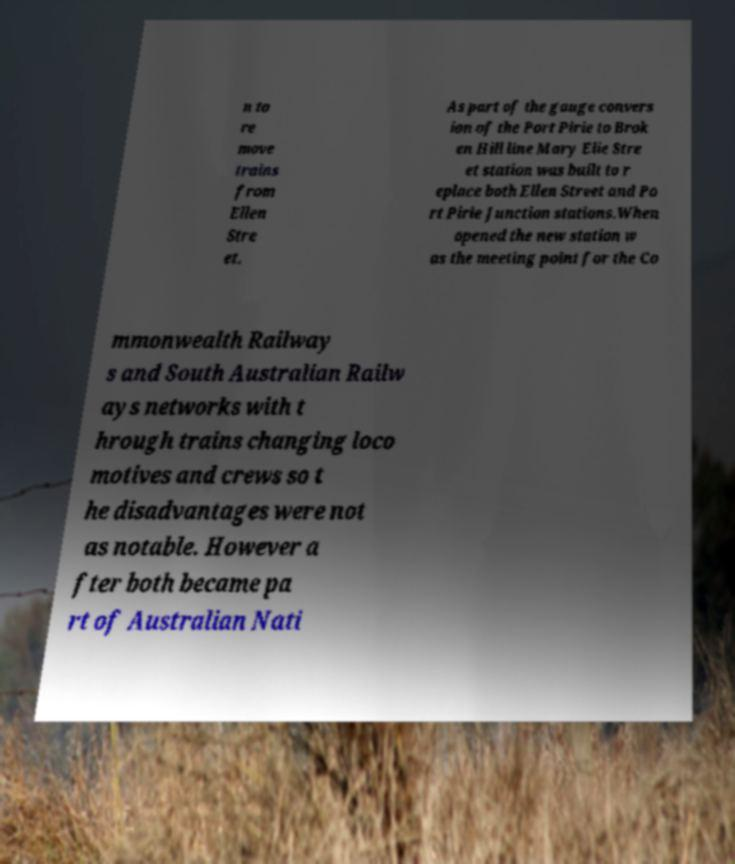Can you accurately transcribe the text from the provided image for me? n to re move trains from Ellen Stre et. As part of the gauge convers ion of the Port Pirie to Brok en Hill line Mary Elie Stre et station was built to r eplace both Ellen Street and Po rt Pirie Junction stations.When opened the new station w as the meeting point for the Co mmonwealth Railway s and South Australian Railw ays networks with t hrough trains changing loco motives and crews so t he disadvantages were not as notable. However a fter both became pa rt of Australian Nati 